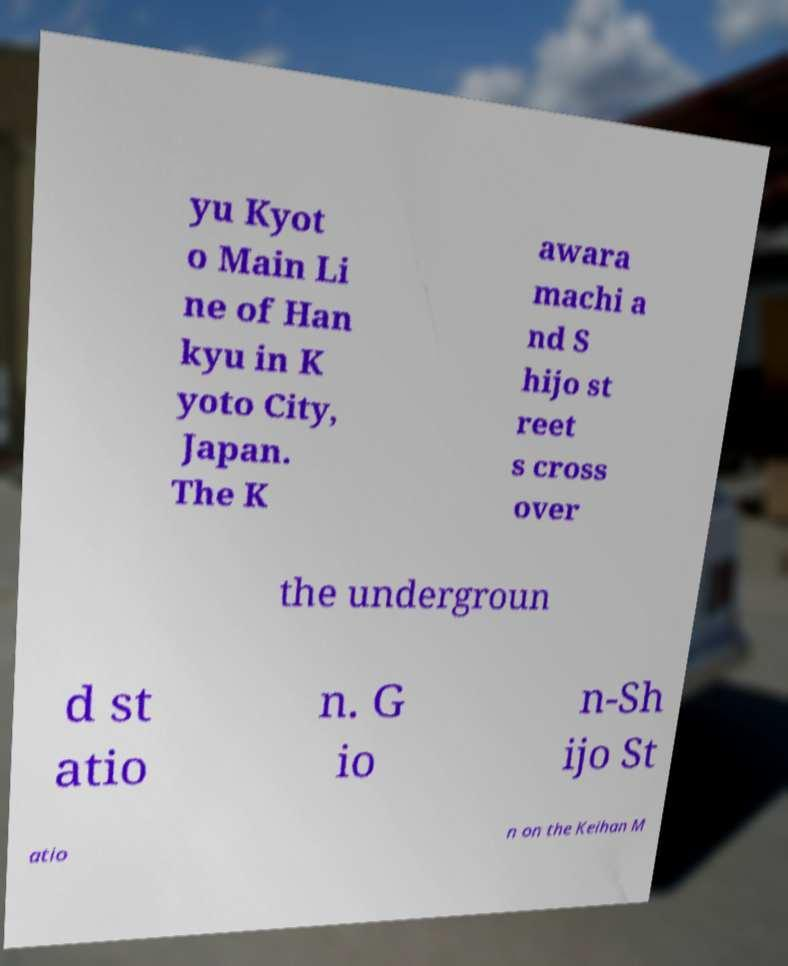I need the written content from this picture converted into text. Can you do that? yu Kyot o Main Li ne of Han kyu in K yoto City, Japan. The K awara machi a nd S hijo st reet s cross over the undergroun d st atio n. G io n-Sh ijo St atio n on the Keihan M 